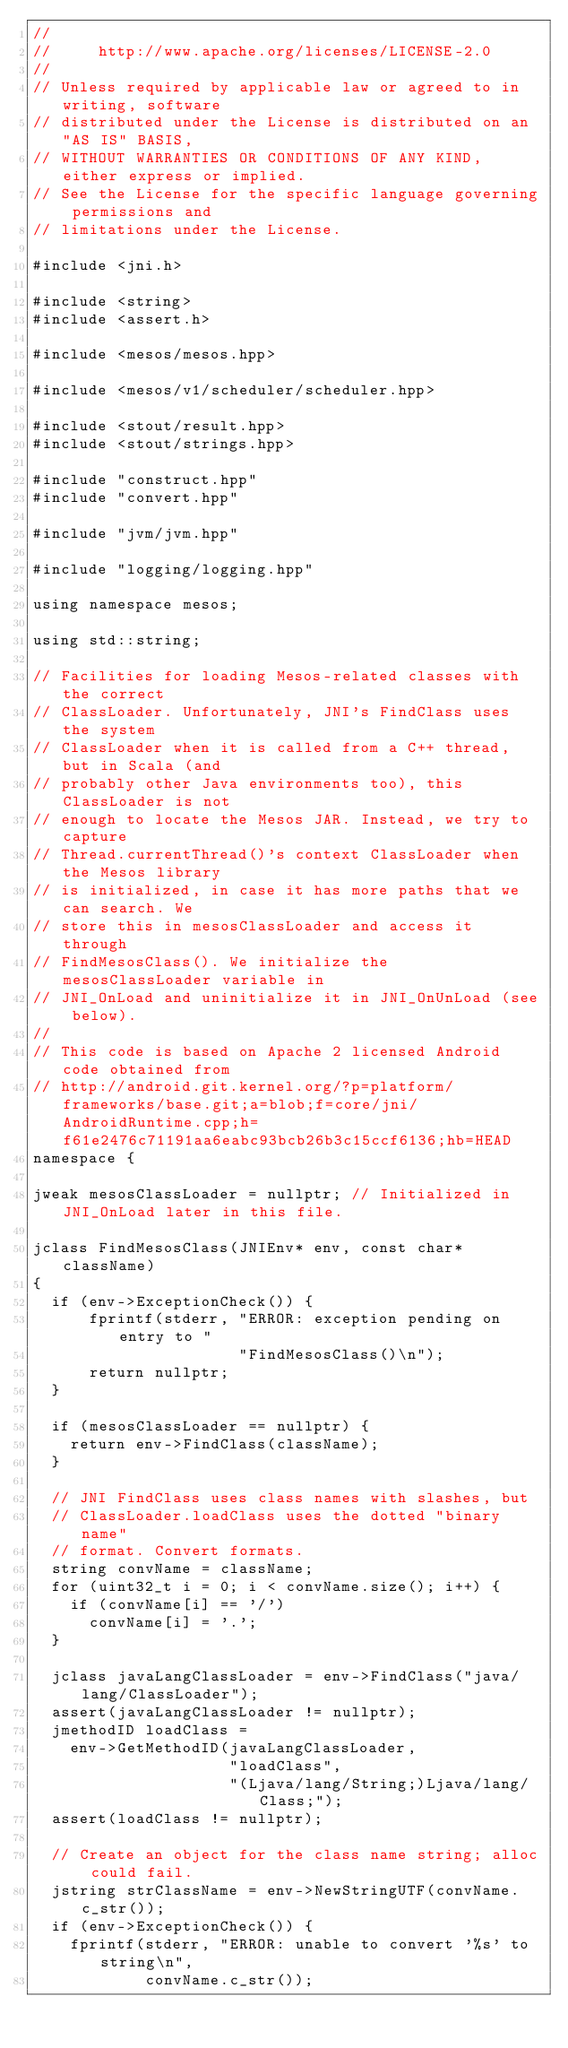Convert code to text. <code><loc_0><loc_0><loc_500><loc_500><_C++_>//
//     http://www.apache.org/licenses/LICENSE-2.0
//
// Unless required by applicable law or agreed to in writing, software
// distributed under the License is distributed on an "AS IS" BASIS,
// WITHOUT WARRANTIES OR CONDITIONS OF ANY KIND, either express or implied.
// See the License for the specific language governing permissions and
// limitations under the License.

#include <jni.h>

#include <string>
#include <assert.h>

#include <mesos/mesos.hpp>

#include <mesos/v1/scheduler/scheduler.hpp>

#include <stout/result.hpp>
#include <stout/strings.hpp>

#include "construct.hpp"
#include "convert.hpp"

#include "jvm/jvm.hpp"

#include "logging/logging.hpp"

using namespace mesos;

using std::string;

// Facilities for loading Mesos-related classes with the correct
// ClassLoader. Unfortunately, JNI's FindClass uses the system
// ClassLoader when it is called from a C++ thread, but in Scala (and
// probably other Java environments too), this ClassLoader is not
// enough to locate the Mesos JAR. Instead, we try to capture
// Thread.currentThread()'s context ClassLoader when the Mesos library
// is initialized, in case it has more paths that we can search. We
// store this in mesosClassLoader and access it through
// FindMesosClass(). We initialize the mesosClassLoader variable in
// JNI_OnLoad and uninitialize it in JNI_OnUnLoad (see below).
//
// This code is based on Apache 2 licensed Android code obtained from
// http://android.git.kernel.org/?p=platform/frameworks/base.git;a=blob;f=core/jni/AndroidRuntime.cpp;h=f61e2476c71191aa6eabc93bcb26b3c15ccf6136;hb=HEAD
namespace {

jweak mesosClassLoader = nullptr; // Initialized in JNI_OnLoad later in this file.

jclass FindMesosClass(JNIEnv* env, const char* className)
{
  if (env->ExceptionCheck()) {
      fprintf(stderr, "ERROR: exception pending on entry to "
                      "FindMesosClass()\n");
      return nullptr;
  }

  if (mesosClassLoader == nullptr) {
    return env->FindClass(className);
  }

  // JNI FindClass uses class names with slashes, but
  // ClassLoader.loadClass uses the dotted "binary name"
  // format. Convert formats.
  string convName = className;
  for (uint32_t i = 0; i < convName.size(); i++) {
    if (convName[i] == '/')
      convName[i] = '.';
  }

  jclass javaLangClassLoader = env->FindClass("java/lang/ClassLoader");
  assert(javaLangClassLoader != nullptr);
  jmethodID loadClass =
    env->GetMethodID(javaLangClassLoader,
                     "loadClass",
                     "(Ljava/lang/String;)Ljava/lang/Class;");
  assert(loadClass != nullptr);

  // Create an object for the class name string; alloc could fail.
  jstring strClassName = env->NewStringUTF(convName.c_str());
  if (env->ExceptionCheck()) {
    fprintf(stderr, "ERROR: unable to convert '%s' to string\n",
            convName.c_str());</code> 